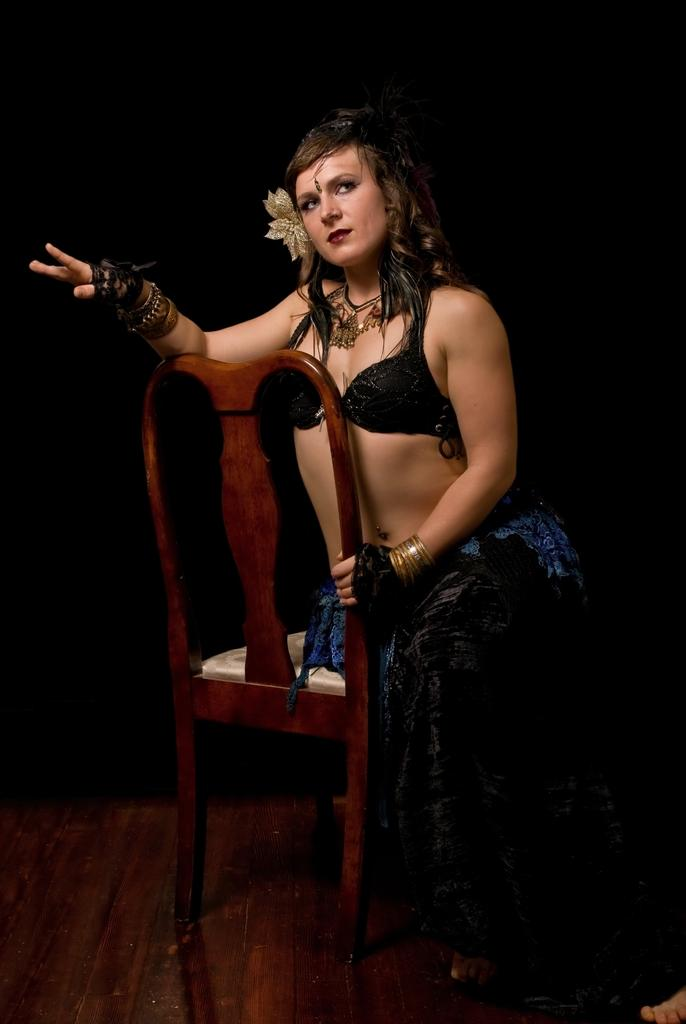Who is the main subject in the image? There is a lady in the image. Where is the lady located in the image? The lady is in the center of the image. What is the lady doing in the image? The lady is sitting on a chair. What type of attraction can be seen in the background of the image? There is no attraction visible in the image; it only features a lady sitting on a chair. 